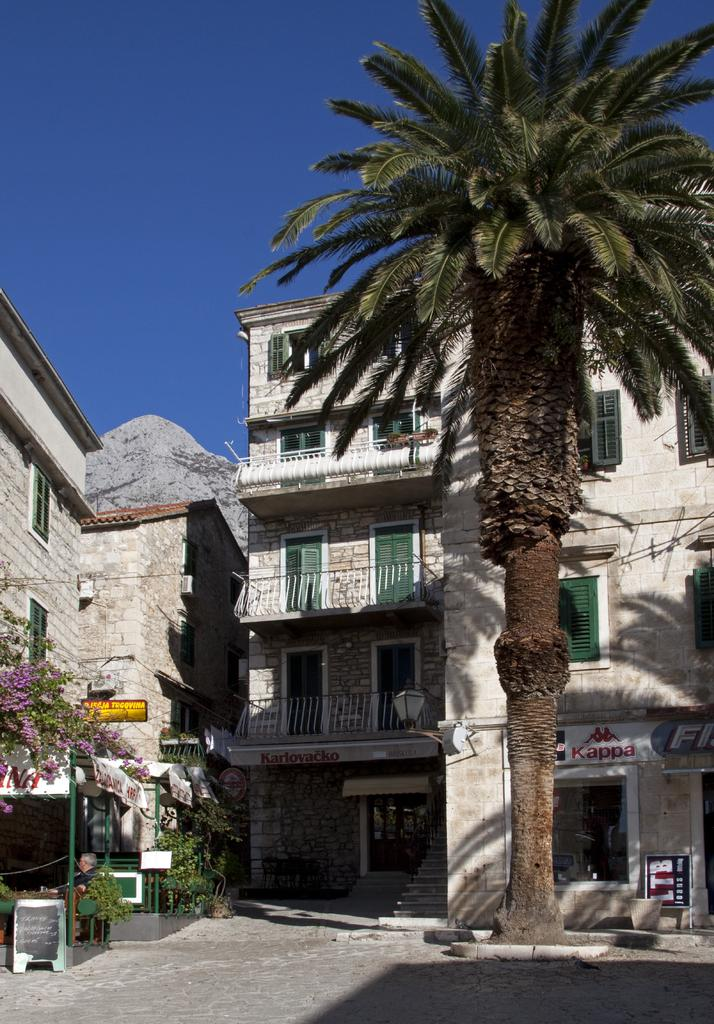<image>
Write a terse but informative summary of the picture. a building that has a red sign that says 'kappa' on it 